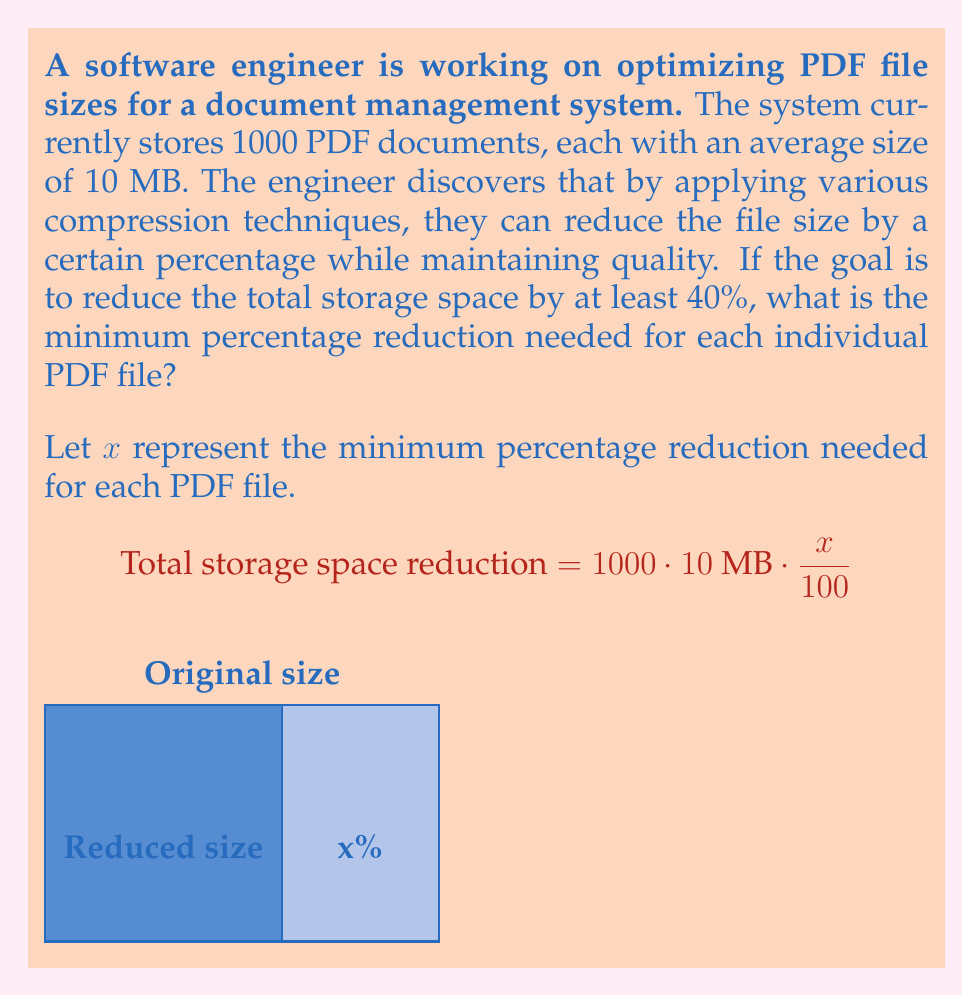Can you answer this question? Let's approach this step-by-step:

1) First, we need to calculate the total current storage space:
   $$\text{Total storage} = 1000 \cdot 10 \text{ MB} = 10,000 \text{ MB}$$

2) The goal is to reduce this by at least 40%:
   $$\text{Minimum reduction} = 40\% \text{ of } 10,000 \text{ MB} = 0.4 \cdot 10,000 \text{ MB} = 4,000 \text{ MB}$$

3) Now, we can set up an equation. The total reduction should be at least 4,000 MB:
   $$1000 \cdot 10 \text{ MB} \cdot \frac{x}{100} \geq 4,000 \text{ MB}$$

4) Simplify:
   $$10,000 \cdot \frac{x}{100} \geq 4,000$$
   $$100x \geq 4,000$$

5) Solve for x:
   $$x \geq \frac{4,000}{100} = 40$$

Therefore, each PDF file needs to be reduced by at least 40% to achieve the overall storage reduction goal.
Answer: 40% 